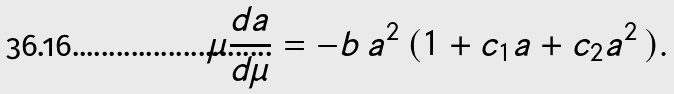<formula> <loc_0><loc_0><loc_500><loc_500>\mu \frac { d a } { d \mu } = - b \, a ^ { 2 } \, ( 1 + c _ { 1 } a + c _ { 2 } a ^ { 2 } \, ) .</formula> 